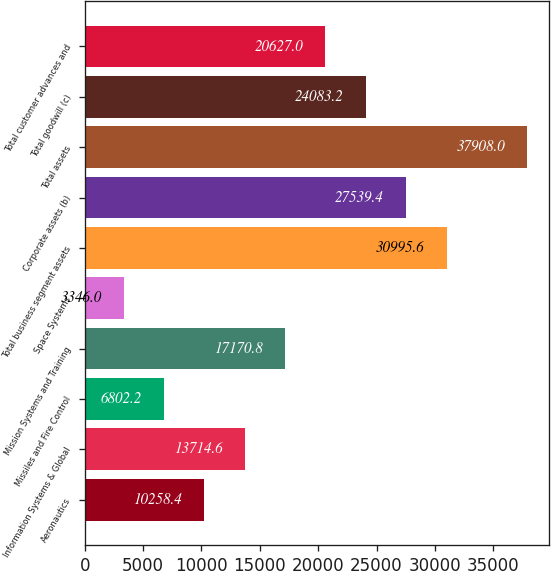<chart> <loc_0><loc_0><loc_500><loc_500><bar_chart><fcel>Aeronautics<fcel>Information Systems & Global<fcel>Missiles and Fire Control<fcel>Mission Systems and Training<fcel>Space Systems<fcel>Total business segment assets<fcel>Corporate assets (b)<fcel>Total assets<fcel>Total goodwill (c)<fcel>Total customer advances and<nl><fcel>10258.4<fcel>13714.6<fcel>6802.2<fcel>17170.8<fcel>3346<fcel>30995.6<fcel>27539.4<fcel>37908<fcel>24083.2<fcel>20627<nl></chart> 